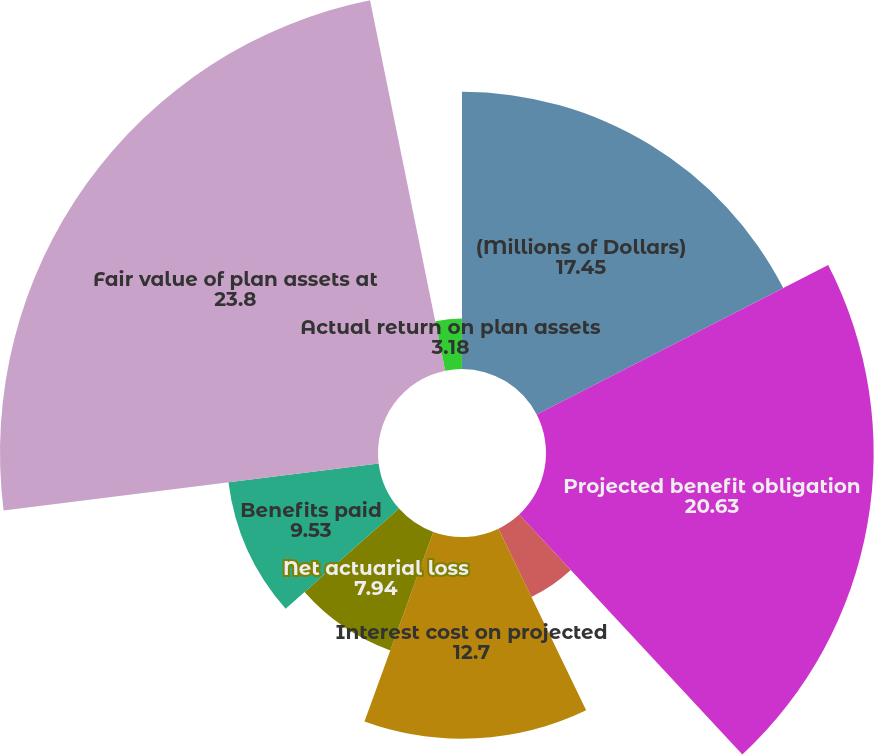<chart> <loc_0><loc_0><loc_500><loc_500><pie_chart><fcel>(Millions of Dollars)<fcel>Projected benefit obligation<fcel>Service cost - excluding<fcel>Interest cost on projected<fcel>Net actuarial loss<fcel>Benefits paid<fcel>Fair value of plan assets at<fcel>Actual return on plan assets<fcel>Employer contributions<nl><fcel>17.45%<fcel>20.63%<fcel>4.77%<fcel>12.7%<fcel>7.94%<fcel>9.53%<fcel>23.8%<fcel>3.18%<fcel>0.01%<nl></chart> 